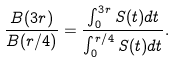Convert formula to latex. <formula><loc_0><loc_0><loc_500><loc_500>\frac { B ( 3 r ) } { B ( r / 4 ) } = \frac { \int _ { 0 } ^ { 3 r } S ( t ) d t } { \int _ { 0 } ^ { r / 4 } S ( t ) d t } .</formula> 